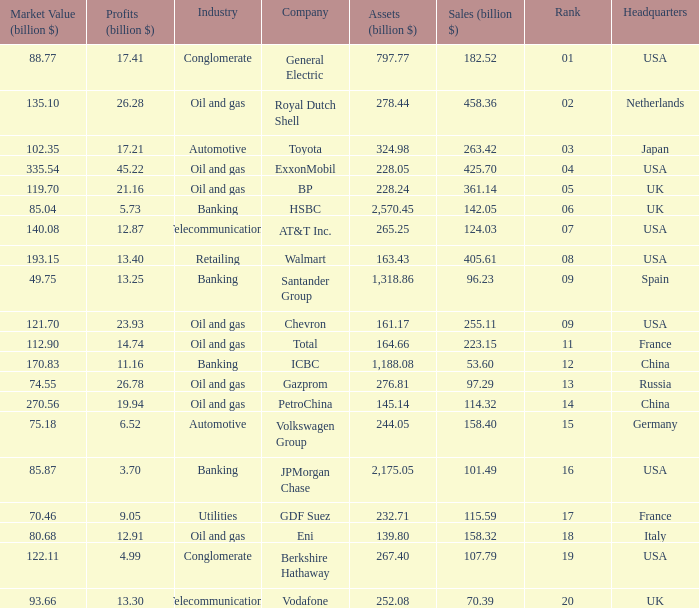Identify the minimum profits (billion $) for a company with 425.7 billion dollars in sales and a ranking higher than 4? None. 